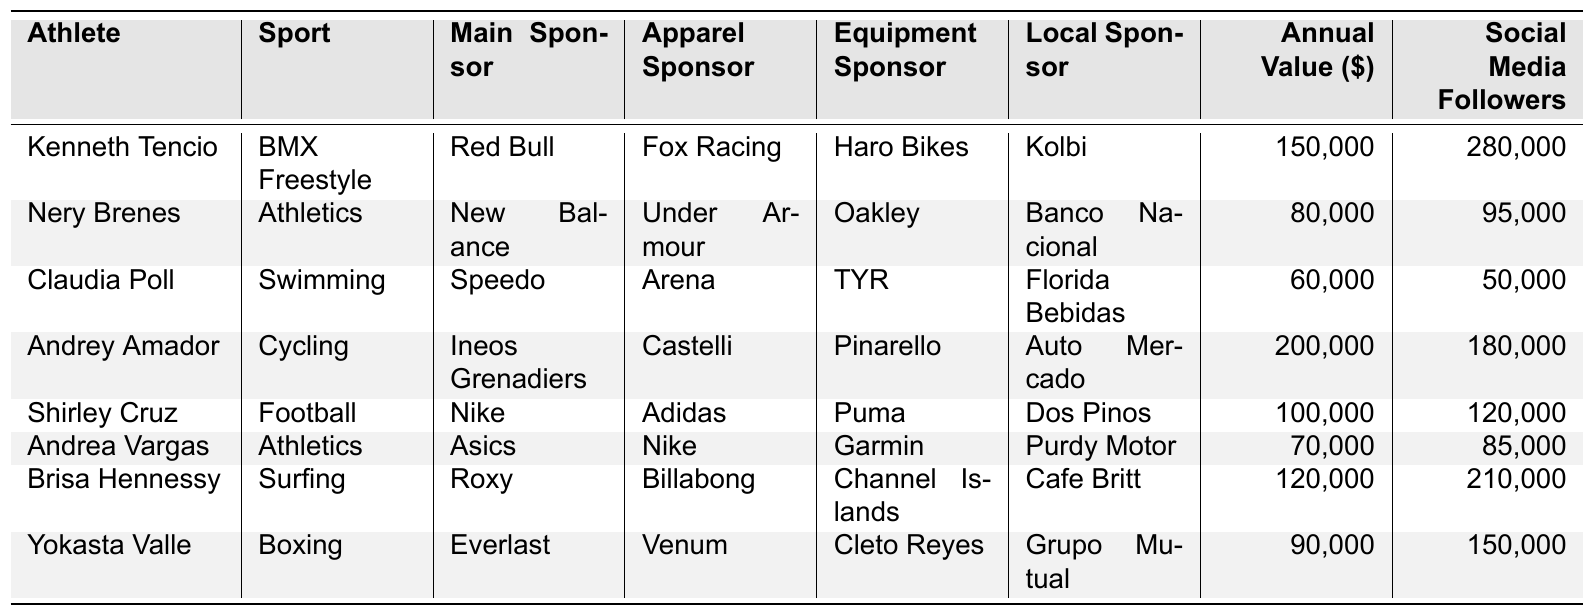What is the main sponsor of Claudia Poll? According to the table, Claudia Poll's main sponsor is Speedo.
Answer: Speedo Which athlete has the highest annual sponsorship value? By examining the table, Andrey Amador has the highest annual sponsorship value at $200,000.
Answer: $200,000 How many social media followers does Shirley Cruz have? The table indicates that Shirley Cruz has 120,000 social media followers.
Answer: 120,000 What is the total annual sponsorship value of all athletes listed? Adding up the annual sponsorship values: 150,000 + 80,000 + 60,000 + 200,000 + 100,000 + 70,000 + 120,000 + 90,000 = 870,000.
Answer: $870,000 Is Brisa Hennessy sponsored by Roxy? The table confirms that Brisa Hennessy's main sponsor is Roxy, making the statement true.
Answer: True What is the difference in social media followers between Kenneth Tencio and Yokasta Valle? Kenneth Tencio has 280,000 followers and Yokasta Valle has 150,000 followers. The difference is 280,000 - 150,000 = 130,000.
Answer: 130,000 What is the average annual sponsorship value among the athletes? There are 8 athletes. The total annual sponsorship value is $870,000. The average is 870,000 / 8 = 108,750.
Answer: $108,750 Which athlete has the least social media followers and what is that number? By inspecting the table, Claudia Poll has the least social media followers with a count of 50,000.
Answer: 50,000 What is the main sponsor for athletes in athletics? There are two athletes in athletics: Nery Brenes is sponsored by New Balance and Andrea Vargas by Asics.
Answer: New Balance and Asics How many athletes have local sponsors that start with the letter 'K'? According to the table, only Kenneth Tencio has a local sponsor starting with 'K' (Kolbi). Therefore, the count is 1.
Answer: 1 